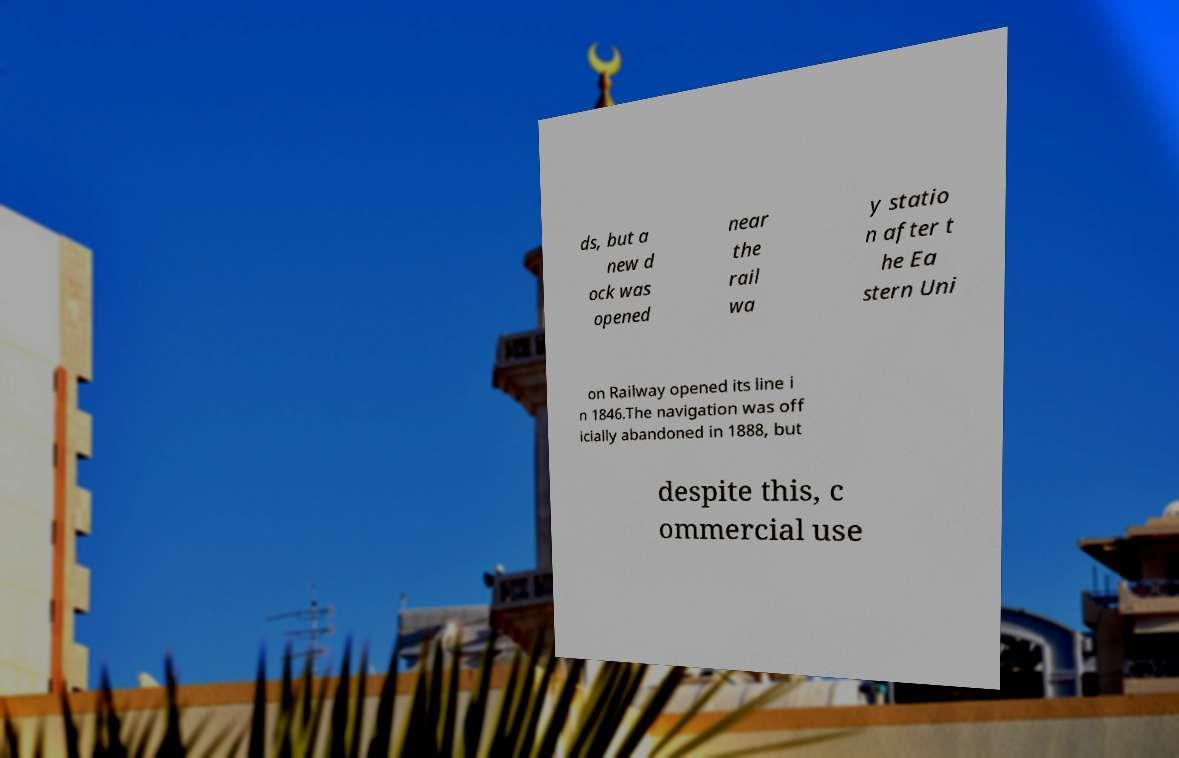Please read and relay the text visible in this image. What does it say? ds, but a new d ock was opened near the rail wa y statio n after t he Ea stern Uni on Railway opened its line i n 1846.The navigation was off icially abandoned in 1888, but despite this, c ommercial use 